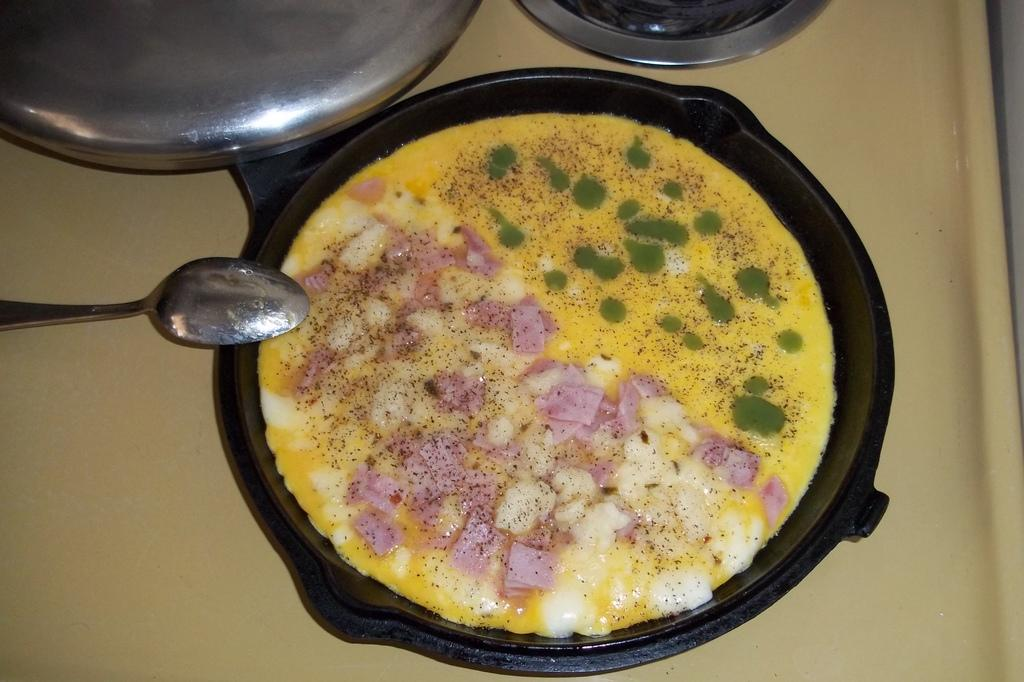What is in the pan that is visible in the image? There is a pan with food in the image. Besides the pan, what other items can be seen in the image? There are additional utensils in the image. Which utensil is specifically visible in the image? A spoon is visible in the image. What color is the surface on which the pan and utensils are placed? The surface in the image is yellow. What language is spoken by the brother in the image? There is no brother or language spoken in the image; it only features a pan with food, utensils, and a yellow surface. 